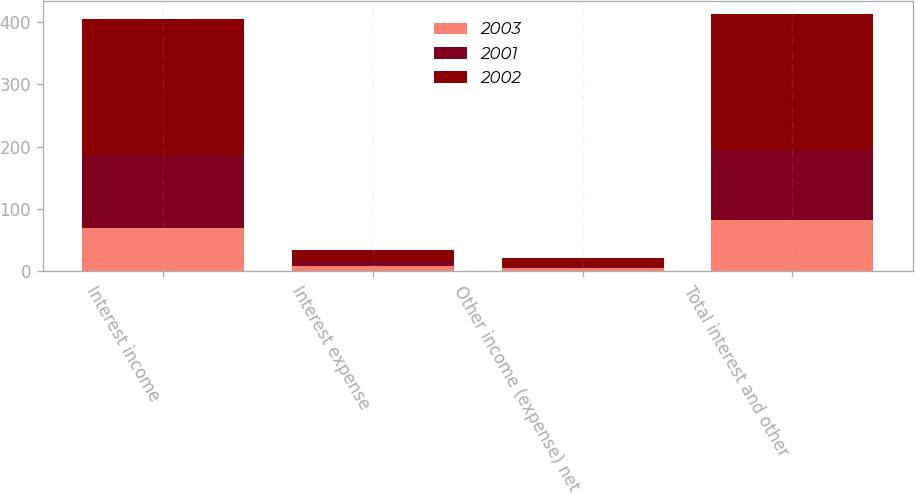Convert chart to OTSL. <chart><loc_0><loc_0><loc_500><loc_500><stacked_bar_chart><ecel><fcel>Interest income<fcel>Interest expense<fcel>Other income (expense) net<fcel>Total interest and other<nl><fcel>2003<fcel>69<fcel>8<fcel>5<fcel>83<nl><fcel>2001<fcel>118<fcel>11<fcel>2<fcel>112<nl><fcel>2002<fcel>218<fcel>16<fcel>15<fcel>217<nl></chart> 